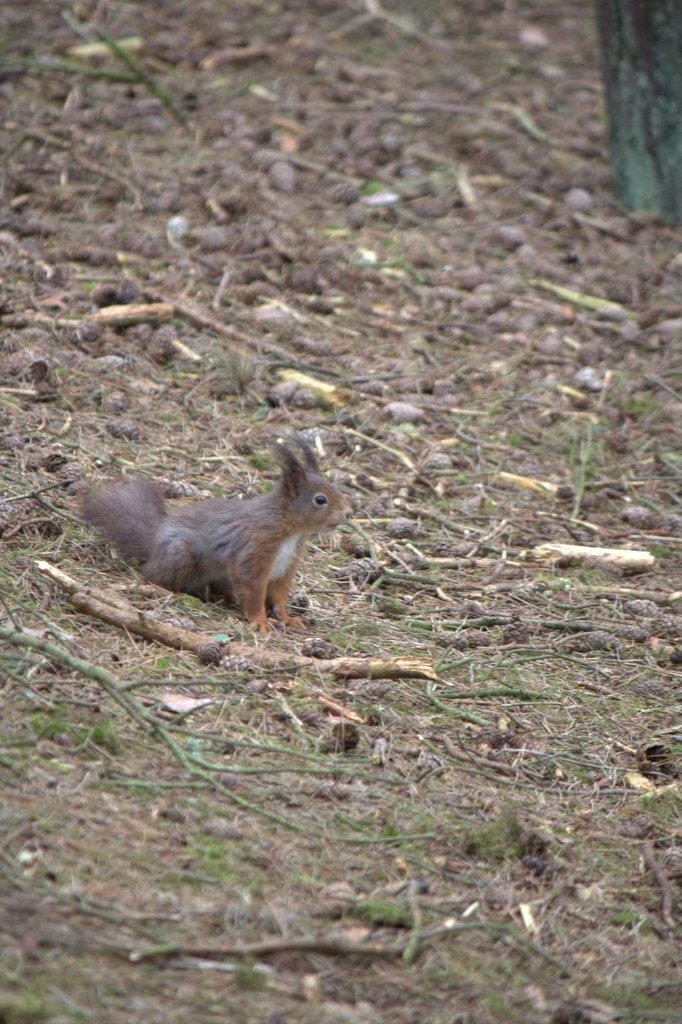What type of animal is in the image? There is a squirrel in the image. What is the squirrel standing on? The squirrel is standing on land. What is the land covered with? The land is covered with twigs, grass, and sand. What type of butter can be seen melting on the squirrel in the image? There is no butter present in the image, and the squirrel is not shown with any butter on it. 